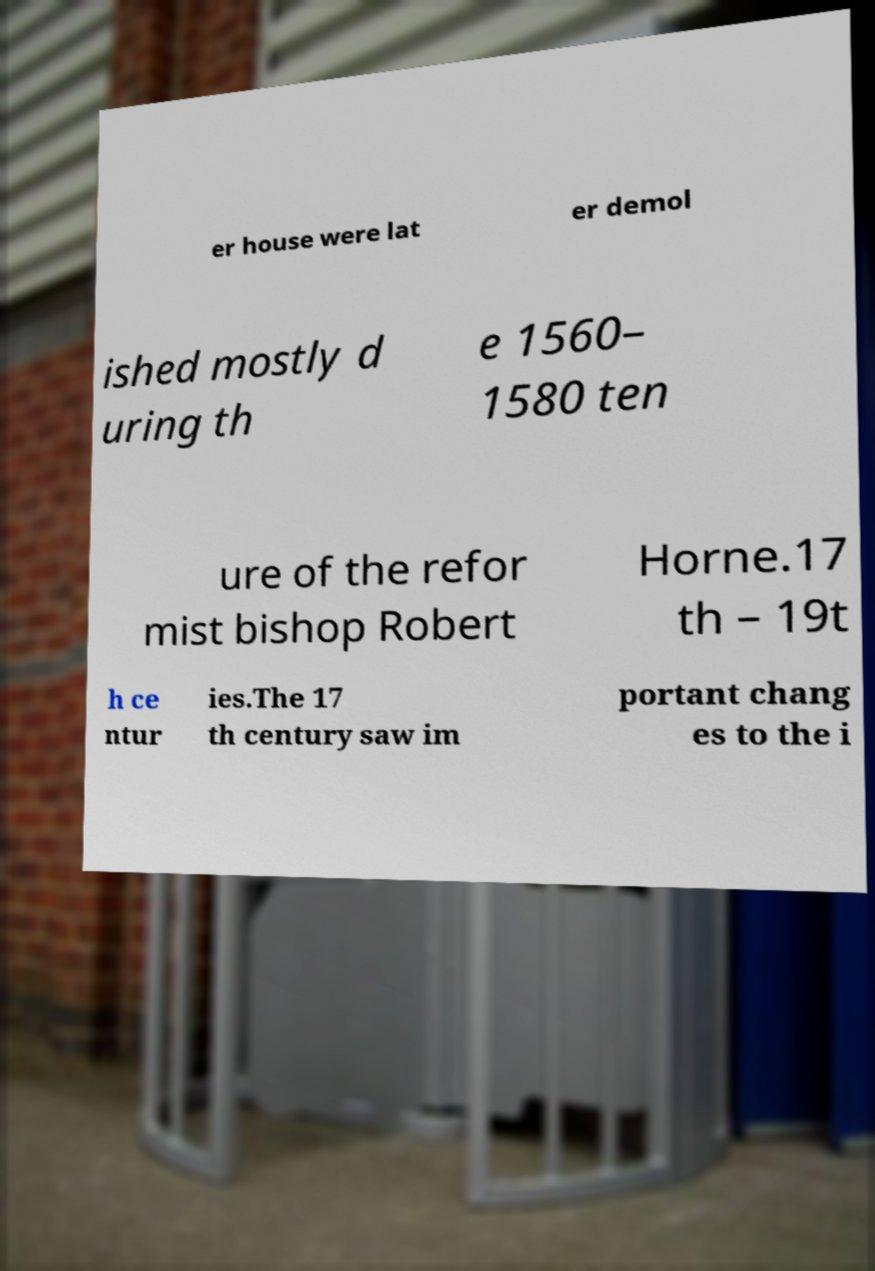Could you assist in decoding the text presented in this image and type it out clearly? er house were lat er demol ished mostly d uring th e 1560– 1580 ten ure of the refor mist bishop Robert Horne.17 th – 19t h ce ntur ies.The 17 th century saw im portant chang es to the i 